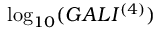Convert formula to latex. <formula><loc_0><loc_0><loc_500><loc_500>\log _ { 1 0 } ( G A L I ^ { ( 4 ) } )</formula> 